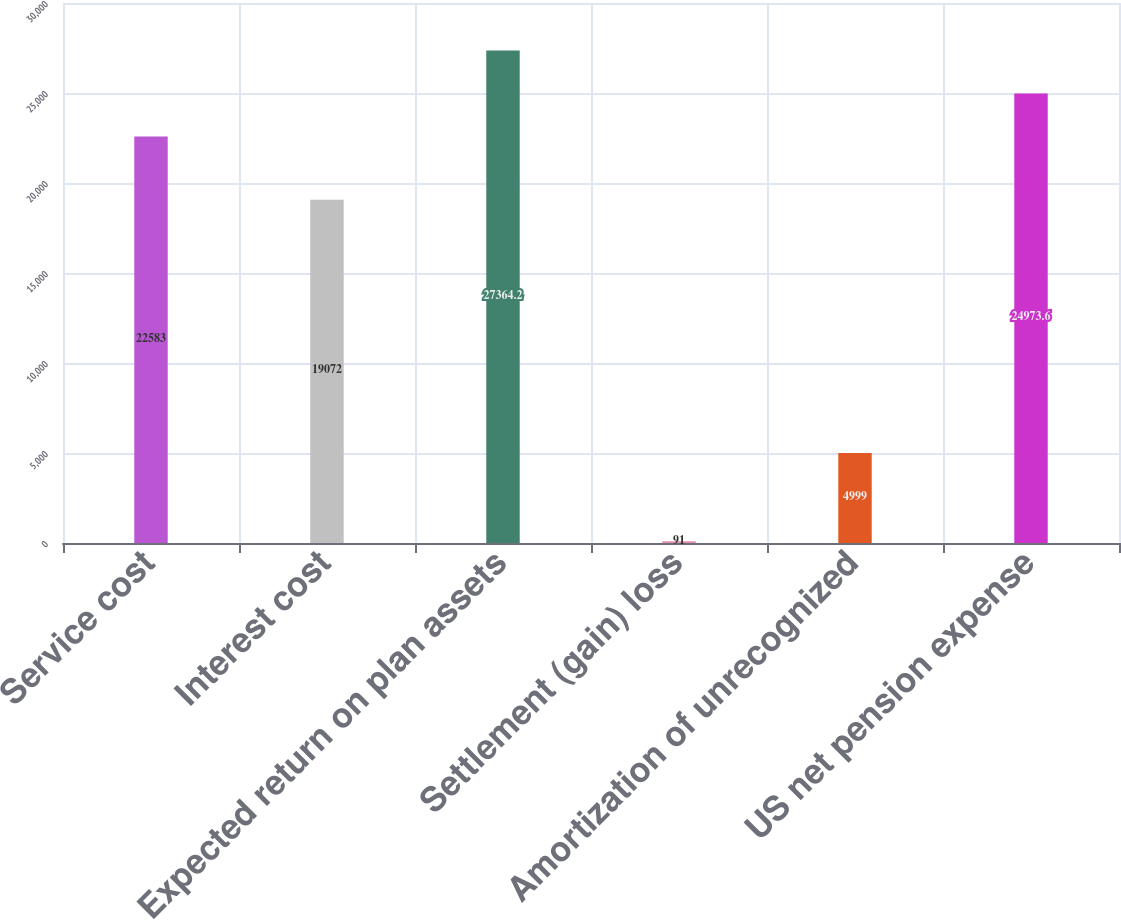Convert chart. <chart><loc_0><loc_0><loc_500><loc_500><bar_chart><fcel>Service cost<fcel>Interest cost<fcel>Expected return on plan assets<fcel>Settlement (gain) loss<fcel>Amortization of unrecognized<fcel>US net pension expense<nl><fcel>22583<fcel>19072<fcel>27364.2<fcel>91<fcel>4999<fcel>24973.6<nl></chart> 